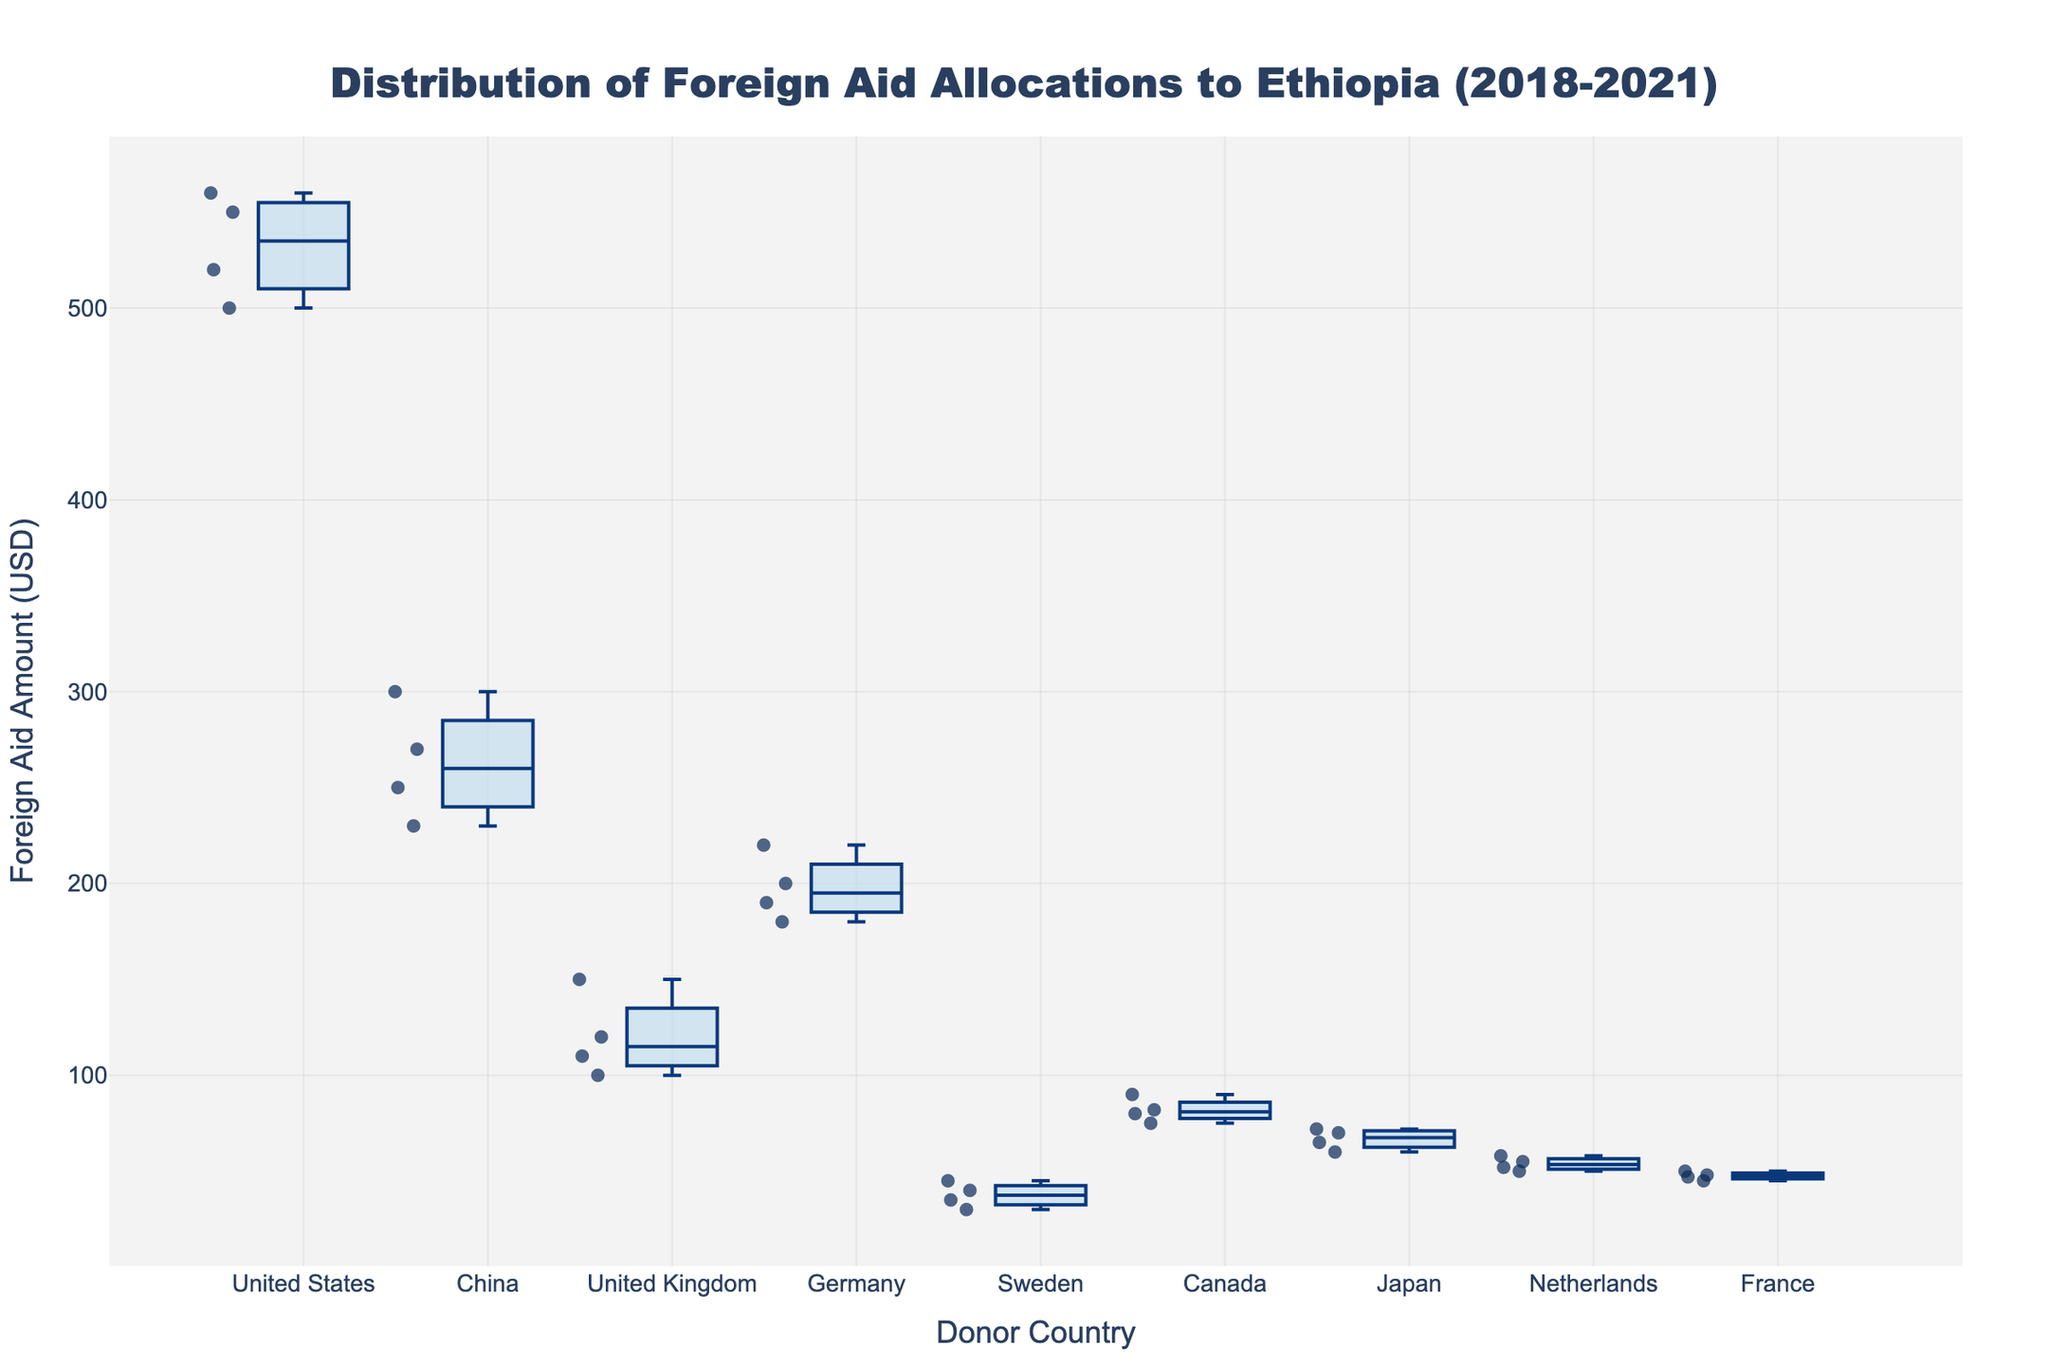Which country provided the highest amount of foreign aid to Ethiopia in 2021? From the figure, observe the scatter points for each country. The point representing the highest aid in 2021 is from the United States with an aid amount of $560,000,000.
Answer: United States What is the median foreign aid amount from China over the period 2018-2021? To find the median, look at the middle value of the sorted data points for China's foreign aid amounts. The values are $230,000,000, $250,000,000, $270,000,000, $300,000,000, so the median is $(250,000,000 + 270,000,000)/2 = 260,000,000$.
Answer: $260,000,000 How does the foreign aid amount from Sweden in 2021 compare to its amount in 2018? Identify the scatter points for Sweden in 2021 and 2018. In 2018, it is $30,000,000, and in 2021, it is $45,000,000. The 2021 amount is greater by $15,000,000.
Answer: $15,000,000 more Which country shows the least variability in its foreign aid amounts to Ethiopia? Look at the spread of the box plots. The United Kingdom has the least variability, as indicated by the small range between the whiskers.
Answer: United Kingdom What is the interquartile range (IQR) for foreign aid from Germany? The IQR is the difference between the 75th percentile (Q3) and the 25th percentile (Q1) of Germany's data. From the box plot, Q3 is approximated at $210,000,000 and Q1 at $180,000,000. IQR = $210,000,000 - $180,000,000 = $30,000,000.
Answer: $30,000,000 Which donor country provided more foreign aid to Ethiopia in 2019: Canada or Japan? Compare the scatter points for Canada and Japan in 2019. Canada's aid was $75,000,000, while Japan's was $65,000,000. Canada provided more.
Answer: Canada What is the approximate range of foreign aid amounts provided by France over the period 2018-2021? Range is the difference between the maximum and minimum values. For France, max is $50,000,000 (2021) and min is $45,000,000 (2018), so the range is $50,000,000 - $45,000,000 = $5,000,000.
Answer: $5,000,000 Between 2018 to 2021, which year had the highest total foreign aid amount from all donor countries combined? Sum the foreign aid amounts for all countries for each year. 2021: $(560 + 300 + 110 + 190 + 45 + 90 + 72 + 58 + 50) = \$1,475M; 2020: $(520 + 270 + 120 + 220 + 35 + 82 + 70 + 52 + 48) = \$1,417M; 2019: $(550 + 230 + 150 + 180 + 40 + 75 + 65 + 55 + 47) = \$1,392M; 2018: $(500 + 250 + 100 + 200 + 30 + 80 + 60 + 50 + 45) = \$1,315M; thus 2021 has the highest total.
Answer: 2021 How does the average foreign aid amount from the United States compare to that from Germany? Calculate the average for both: US: $(500 + 550 + 520 + 560) / 4 = 532.5M; Germany: $(200 + 180 + 220 + 190) / 4 = 197.5M. The US has a higher average by $532.5M - $197.5M = $335M.
Answer: $335M higher Which country had the largest increase in foreign aid from 2018 to 2021? Calculate the difference for each country from 2018 to 2021: US: $60M, China: $50M, UK: $10M, Germany: -$10M, Sweden: $15M, Canada: $10M, Japan: $12M, Netherlands: $8M, France: $5M. The largest increase is for the US.
Answer: United States 